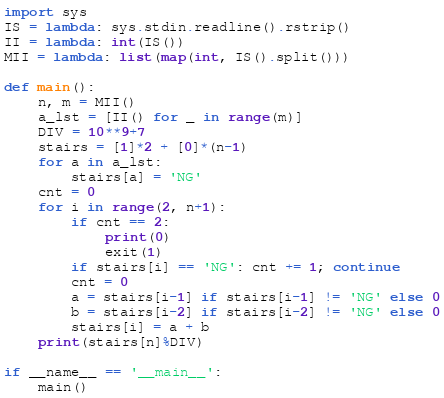Convert code to text. <code><loc_0><loc_0><loc_500><loc_500><_Python_>import sys
IS = lambda: sys.stdin.readline().rstrip()
II = lambda: int(IS())
MII = lambda: list(map(int, IS().split()))

def main():
    n, m = MII()
    a_lst = [II() for _ in range(m)]
    DIV = 10**9+7
    stairs = [1]*2 + [0]*(n-1)
    for a in a_lst:
        stairs[a] = 'NG'
    cnt = 0
    for i in range(2, n+1):
        if cnt == 2:
            print(0)
            exit(1)
        if stairs[i] == 'NG': cnt += 1; continue
        cnt = 0
        a = stairs[i-1] if stairs[i-1] != 'NG' else 0
        b = stairs[i-2] if stairs[i-2] != 'NG' else 0
        stairs[i] = a + b
    print(stairs[n]%DIV)

if __name__ == '__main__':
    main()
</code> 